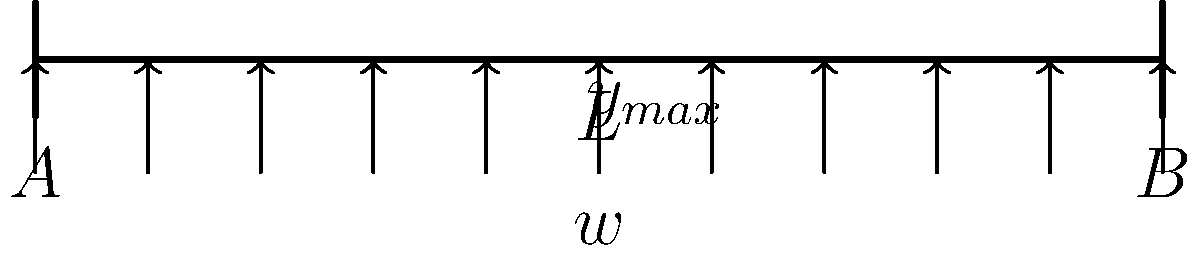As a product manager reviewing the structural integrity of a new tech gadget, you encounter a scenario where a component can be modeled as a simply supported beam under a uniformly distributed load. The beam has a length $L$ of 2 meters and is subjected to a uniform load $w$ of 500 N/m. Given that the beam is made of aluminum with a Young's modulus $E$ of 69 GPa and a moment of inertia $I$ of $1.5 \times 10^{-6}$ m⁴, calculate the maximum deflection $y_{max}$ at the center of the beam. To solve this problem, we'll use the formula for maximum deflection of a simply supported beam under uniformly distributed load:

$$y_{max} = \frac{5wL^4}{384EI}$$

Where:
$y_{max}$ = maximum deflection at the center of the beam
$w$ = uniformly distributed load
$L$ = length of the beam
$E$ = Young's modulus
$I$ = moment of inertia

Step 1: Identify the given values
$w = 500$ N/m
$L = 2$ m
$E = 69 \times 10^9$ Pa
$I = 1.5 \times 10^{-6}$ m⁴

Step 2: Substitute the values into the formula
$$y_{max} = \frac{5 \times 500 \times 2^4}{384 \times 69 \times 10^9 \times 1.5 \times 10^{-6}}$$

Step 3: Calculate the result
$$y_{max} = \frac{5 \times 500 \times 16}{384 \times 69 \times 10^9 \times 1.5 \times 10^{-6}}$$
$$y_{max} = \frac{40000}{39744 \times 10^3}$$
$$y_{max} = 1.006 \times 10^{-3}$$ m

Step 4: Convert to millimeters for a more practical unit
$$y_{max} = 1.006 \times 10^{-3} \times 1000 = 1.006$$ mm
Answer: 1.006 mm 